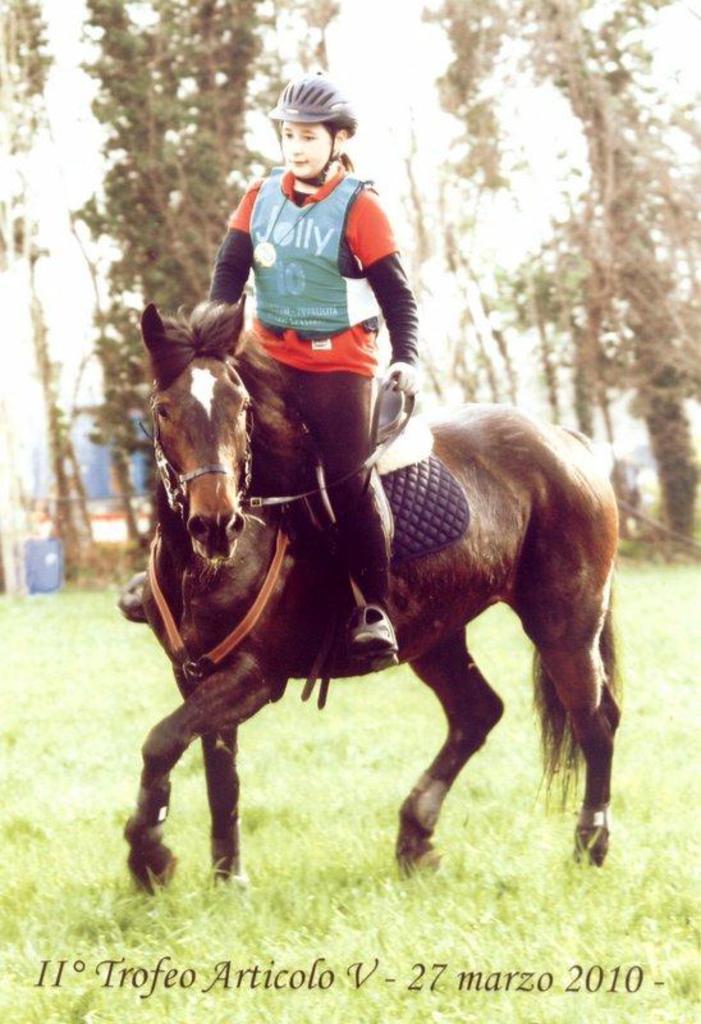Could you give a brief overview of what you see in this image? As we can see in the image there are trees, grass and a woman standing on horse. 